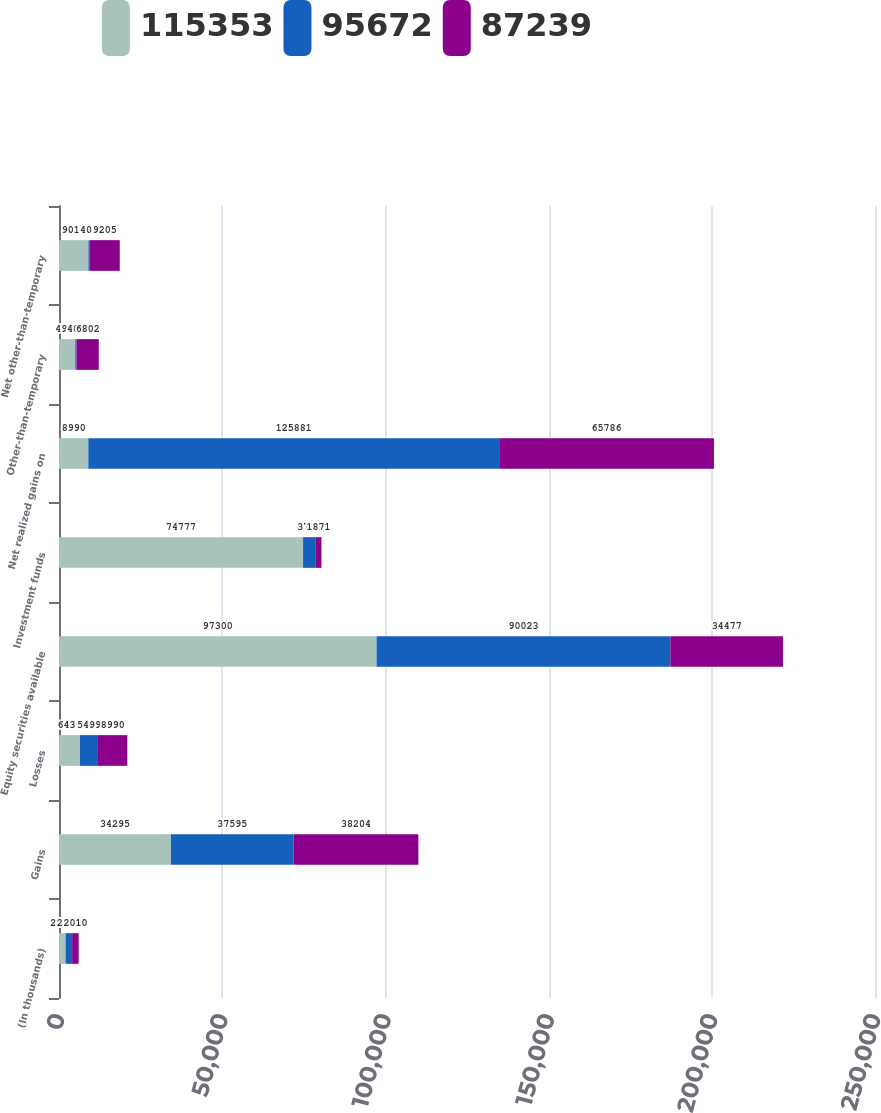Convert chart. <chart><loc_0><loc_0><loc_500><loc_500><stacked_bar_chart><ecel><fcel>(In thousands)<fcel>Gains<fcel>Losses<fcel>Equity securities available<fcel>Investment funds<fcel>Net realized gains on<fcel>Other-than-temporary<fcel>Net other-than-temporary<nl><fcel>115353<fcel>2012<fcel>34295<fcel>6436<fcel>97300<fcel>74777<fcel>8990<fcel>4984<fcel>9014<nl><fcel>95672<fcel>2011<fcel>37595<fcel>5499<fcel>90023<fcel>3762<fcel>125881<fcel>400<fcel>400<nl><fcel>87239<fcel>2010<fcel>38204<fcel>8990<fcel>34477<fcel>1871<fcel>65786<fcel>6802<fcel>9205<nl></chart> 